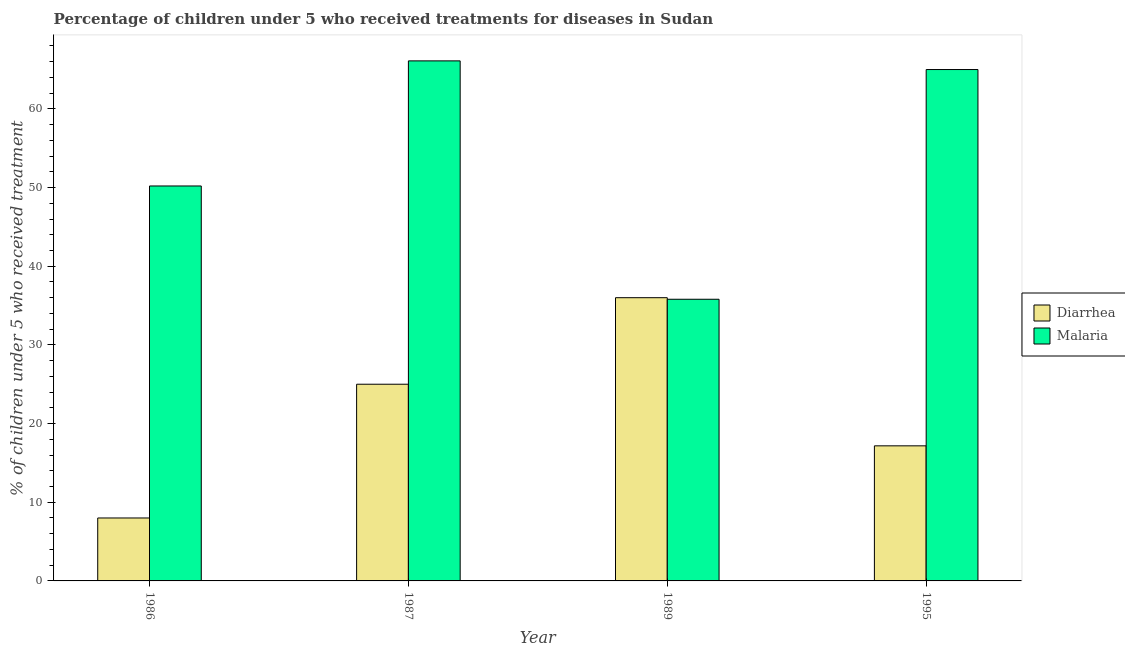How many different coloured bars are there?
Your response must be concise. 2. Are the number of bars per tick equal to the number of legend labels?
Provide a short and direct response. Yes. What is the label of the 3rd group of bars from the left?
Your answer should be compact. 1989. Across all years, what is the minimum percentage of children who received treatment for malaria?
Make the answer very short. 35.8. What is the total percentage of children who received treatment for diarrhoea in the graph?
Provide a succinct answer. 86.17. What is the difference between the percentage of children who received treatment for malaria in 1987 and that in 1995?
Offer a very short reply. 1.1. What is the difference between the percentage of children who received treatment for malaria in 1995 and the percentage of children who received treatment for diarrhoea in 1987?
Give a very brief answer. -1.1. What is the average percentage of children who received treatment for malaria per year?
Provide a succinct answer. 54.27. In how many years, is the percentage of children who received treatment for diarrhoea greater than 12 %?
Offer a terse response. 3. What is the ratio of the percentage of children who received treatment for malaria in 1986 to that in 1987?
Your response must be concise. 0.76. Is the percentage of children who received treatment for malaria in 1986 less than that in 1995?
Offer a very short reply. Yes. Is the difference between the percentage of children who received treatment for malaria in 1986 and 1995 greater than the difference between the percentage of children who received treatment for diarrhoea in 1986 and 1995?
Your answer should be very brief. No. What is the difference between the highest and the second highest percentage of children who received treatment for diarrhoea?
Your response must be concise. 11. What is the difference between the highest and the lowest percentage of children who received treatment for malaria?
Ensure brevity in your answer.  30.3. Is the sum of the percentage of children who received treatment for diarrhoea in 1989 and 1995 greater than the maximum percentage of children who received treatment for malaria across all years?
Provide a short and direct response. Yes. What does the 2nd bar from the left in 1987 represents?
Provide a succinct answer. Malaria. What does the 1st bar from the right in 1986 represents?
Make the answer very short. Malaria. How many bars are there?
Provide a succinct answer. 8. Are all the bars in the graph horizontal?
Your answer should be compact. No. Does the graph contain grids?
Give a very brief answer. No. Where does the legend appear in the graph?
Ensure brevity in your answer.  Center right. How many legend labels are there?
Make the answer very short. 2. How are the legend labels stacked?
Your response must be concise. Vertical. What is the title of the graph?
Provide a short and direct response. Percentage of children under 5 who received treatments for diseases in Sudan. Does "Lowest 10% of population" appear as one of the legend labels in the graph?
Offer a very short reply. No. What is the label or title of the Y-axis?
Give a very brief answer. % of children under 5 who received treatment. What is the % of children under 5 who received treatment of Diarrhea in 1986?
Provide a short and direct response. 8. What is the % of children under 5 who received treatment of Malaria in 1986?
Offer a terse response. 50.2. What is the % of children under 5 who received treatment of Diarrhea in 1987?
Your answer should be very brief. 25. What is the % of children under 5 who received treatment of Malaria in 1987?
Your response must be concise. 66.1. What is the % of children under 5 who received treatment of Diarrhea in 1989?
Offer a terse response. 36. What is the % of children under 5 who received treatment of Malaria in 1989?
Give a very brief answer. 35.8. What is the % of children under 5 who received treatment of Diarrhea in 1995?
Make the answer very short. 17.17. What is the % of children under 5 who received treatment of Malaria in 1995?
Provide a short and direct response. 65. Across all years, what is the maximum % of children under 5 who received treatment of Diarrhea?
Keep it short and to the point. 36. Across all years, what is the maximum % of children under 5 who received treatment in Malaria?
Give a very brief answer. 66.1. Across all years, what is the minimum % of children under 5 who received treatment in Diarrhea?
Offer a very short reply. 8. Across all years, what is the minimum % of children under 5 who received treatment in Malaria?
Ensure brevity in your answer.  35.8. What is the total % of children under 5 who received treatment of Diarrhea in the graph?
Your answer should be compact. 86.17. What is the total % of children under 5 who received treatment of Malaria in the graph?
Your answer should be compact. 217.1. What is the difference between the % of children under 5 who received treatment of Diarrhea in 1986 and that in 1987?
Your answer should be compact. -17. What is the difference between the % of children under 5 who received treatment of Malaria in 1986 and that in 1987?
Give a very brief answer. -15.9. What is the difference between the % of children under 5 who received treatment of Diarrhea in 1986 and that in 1995?
Provide a short and direct response. -9.17. What is the difference between the % of children under 5 who received treatment in Malaria in 1986 and that in 1995?
Your answer should be very brief. -14.8. What is the difference between the % of children under 5 who received treatment in Diarrhea in 1987 and that in 1989?
Provide a short and direct response. -11. What is the difference between the % of children under 5 who received treatment in Malaria in 1987 and that in 1989?
Provide a succinct answer. 30.3. What is the difference between the % of children under 5 who received treatment of Diarrhea in 1987 and that in 1995?
Offer a terse response. 7.83. What is the difference between the % of children under 5 who received treatment in Diarrhea in 1989 and that in 1995?
Make the answer very short. 18.83. What is the difference between the % of children under 5 who received treatment of Malaria in 1989 and that in 1995?
Offer a very short reply. -29.2. What is the difference between the % of children under 5 who received treatment in Diarrhea in 1986 and the % of children under 5 who received treatment in Malaria in 1987?
Your answer should be very brief. -58.1. What is the difference between the % of children under 5 who received treatment in Diarrhea in 1986 and the % of children under 5 who received treatment in Malaria in 1989?
Your response must be concise. -27.8. What is the difference between the % of children under 5 who received treatment of Diarrhea in 1986 and the % of children under 5 who received treatment of Malaria in 1995?
Your response must be concise. -57. What is the difference between the % of children under 5 who received treatment of Diarrhea in 1987 and the % of children under 5 who received treatment of Malaria in 1989?
Your response must be concise. -10.8. What is the difference between the % of children under 5 who received treatment of Diarrhea in 1987 and the % of children under 5 who received treatment of Malaria in 1995?
Provide a succinct answer. -40. What is the difference between the % of children under 5 who received treatment in Diarrhea in 1989 and the % of children under 5 who received treatment in Malaria in 1995?
Your answer should be compact. -29. What is the average % of children under 5 who received treatment of Diarrhea per year?
Keep it short and to the point. 21.54. What is the average % of children under 5 who received treatment of Malaria per year?
Provide a short and direct response. 54.27. In the year 1986, what is the difference between the % of children under 5 who received treatment in Diarrhea and % of children under 5 who received treatment in Malaria?
Your answer should be compact. -42.2. In the year 1987, what is the difference between the % of children under 5 who received treatment in Diarrhea and % of children under 5 who received treatment in Malaria?
Your answer should be very brief. -41.1. In the year 1989, what is the difference between the % of children under 5 who received treatment of Diarrhea and % of children under 5 who received treatment of Malaria?
Your response must be concise. 0.2. In the year 1995, what is the difference between the % of children under 5 who received treatment in Diarrhea and % of children under 5 who received treatment in Malaria?
Your answer should be very brief. -47.83. What is the ratio of the % of children under 5 who received treatment of Diarrhea in 1986 to that in 1987?
Your answer should be very brief. 0.32. What is the ratio of the % of children under 5 who received treatment of Malaria in 1986 to that in 1987?
Your answer should be compact. 0.76. What is the ratio of the % of children under 5 who received treatment in Diarrhea in 1986 to that in 1989?
Ensure brevity in your answer.  0.22. What is the ratio of the % of children under 5 who received treatment in Malaria in 1986 to that in 1989?
Offer a very short reply. 1.4. What is the ratio of the % of children under 5 who received treatment in Diarrhea in 1986 to that in 1995?
Ensure brevity in your answer.  0.47. What is the ratio of the % of children under 5 who received treatment of Malaria in 1986 to that in 1995?
Give a very brief answer. 0.77. What is the ratio of the % of children under 5 who received treatment in Diarrhea in 1987 to that in 1989?
Provide a short and direct response. 0.69. What is the ratio of the % of children under 5 who received treatment in Malaria in 1987 to that in 1989?
Offer a terse response. 1.85. What is the ratio of the % of children under 5 who received treatment of Diarrhea in 1987 to that in 1995?
Offer a terse response. 1.46. What is the ratio of the % of children under 5 who received treatment of Malaria in 1987 to that in 1995?
Keep it short and to the point. 1.02. What is the ratio of the % of children under 5 who received treatment in Diarrhea in 1989 to that in 1995?
Offer a terse response. 2.1. What is the ratio of the % of children under 5 who received treatment of Malaria in 1989 to that in 1995?
Keep it short and to the point. 0.55. What is the difference between the highest and the second highest % of children under 5 who received treatment in Diarrhea?
Your response must be concise. 11. What is the difference between the highest and the lowest % of children under 5 who received treatment of Diarrhea?
Your answer should be compact. 28. What is the difference between the highest and the lowest % of children under 5 who received treatment in Malaria?
Provide a short and direct response. 30.3. 